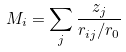<formula> <loc_0><loc_0><loc_500><loc_500>M _ { i } = \sum _ { j } \frac { z _ { j } } { r _ { i j } / r _ { 0 } }</formula> 